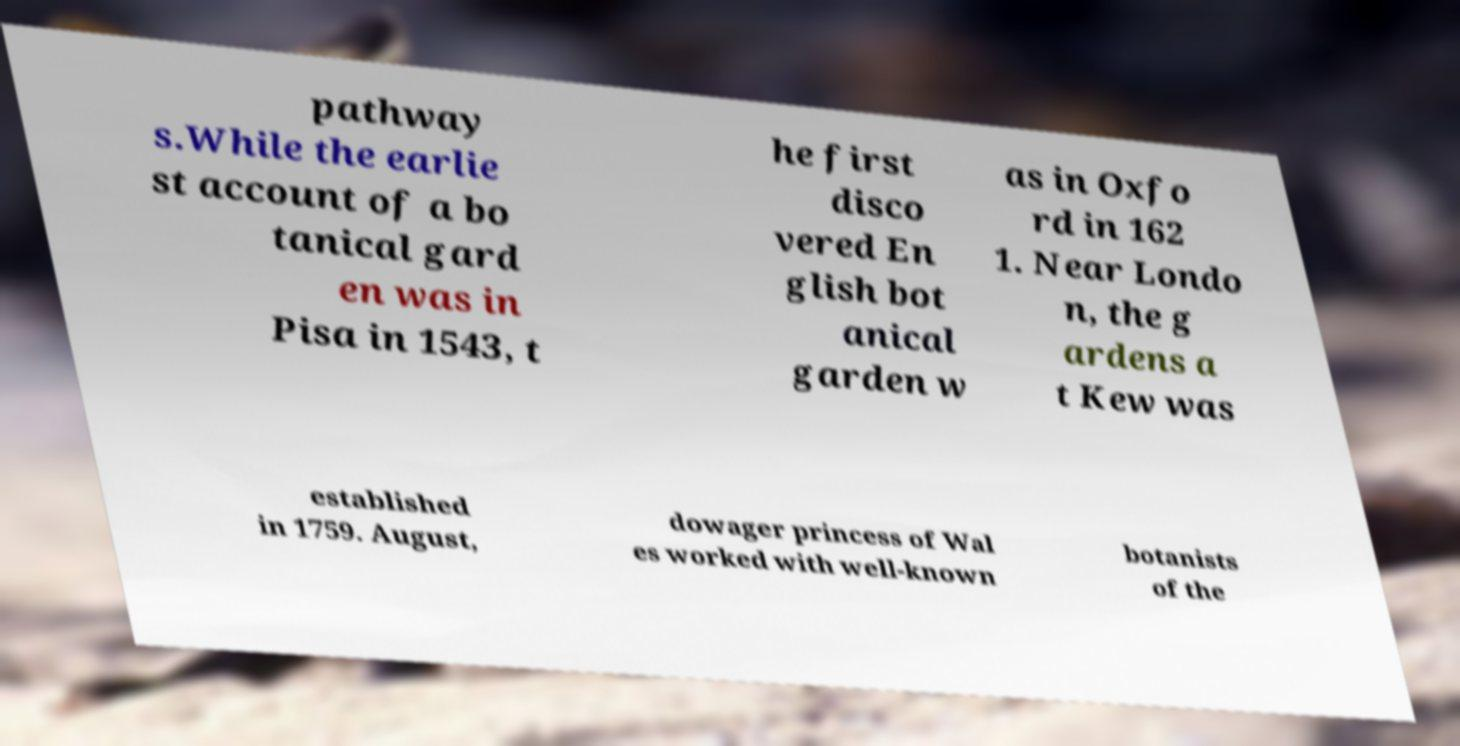What messages or text are displayed in this image? I need them in a readable, typed format. pathway s.While the earlie st account of a bo tanical gard en was in Pisa in 1543, t he first disco vered En glish bot anical garden w as in Oxfo rd in 162 1. Near Londo n, the g ardens a t Kew was established in 1759. August, dowager princess of Wal es worked with well-known botanists of the 